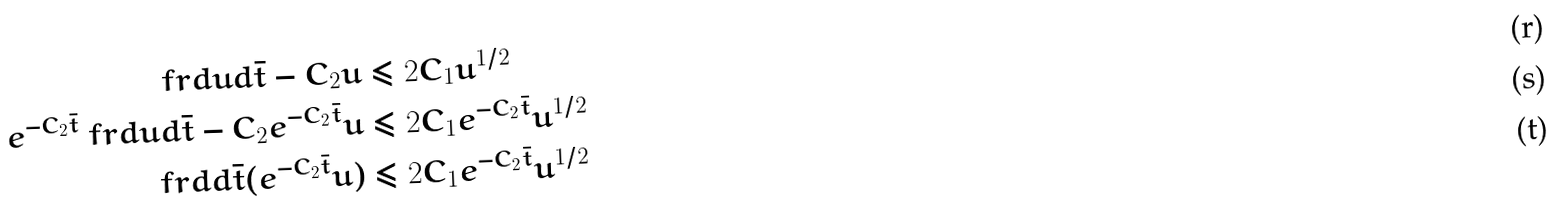<formula> <loc_0><loc_0><loc_500><loc_500>\ f r { d u } { d { \bar { t } } } - C _ { 2 } u & \leq 2 C _ { 1 } u ^ { 1 / 2 } \\ e ^ { - C _ { 2 } { \bar { t } } } \ f r { d u } { d { \bar { t } } } - C _ { 2 } e ^ { - C _ { 2 } { \bar { t } } } u & \leq 2 C _ { 1 } e ^ { - C _ { 2 } { \bar { t } } } u ^ { 1 / 2 } \\ \ f r { d } { d { \bar { t } } } ( e ^ { - C _ { 2 } { \bar { t } } } u ) & \leq 2 C _ { 1 } e ^ { - C _ { 2 } { \bar { t } } } u ^ { 1 / 2 }</formula> 